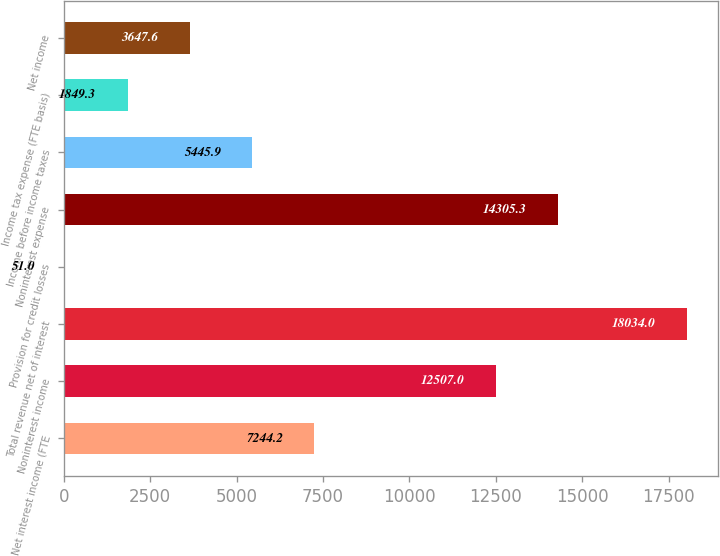Convert chart to OTSL. <chart><loc_0><loc_0><loc_500><loc_500><bar_chart><fcel>Net interest income (FTE<fcel>Noninterest income<fcel>Total revenue net of interest<fcel>Provision for credit losses<fcel>Noninterest expense<fcel>Income before income taxes<fcel>Income tax expense (FTE basis)<fcel>Net income<nl><fcel>7244.2<fcel>12507<fcel>18034<fcel>51<fcel>14305.3<fcel>5445.9<fcel>1849.3<fcel>3647.6<nl></chart> 